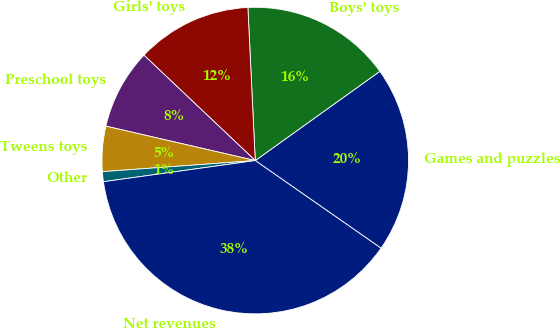Convert chart to OTSL. <chart><loc_0><loc_0><loc_500><loc_500><pie_chart><fcel>Games and puzzles<fcel>Boys' toys<fcel>Girls' toys<fcel>Preschool toys<fcel>Tweens toys<fcel>Other<fcel>Net revenues<nl><fcel>19.58%<fcel>15.87%<fcel>12.17%<fcel>8.46%<fcel>4.76%<fcel>1.05%<fcel>38.11%<nl></chart> 